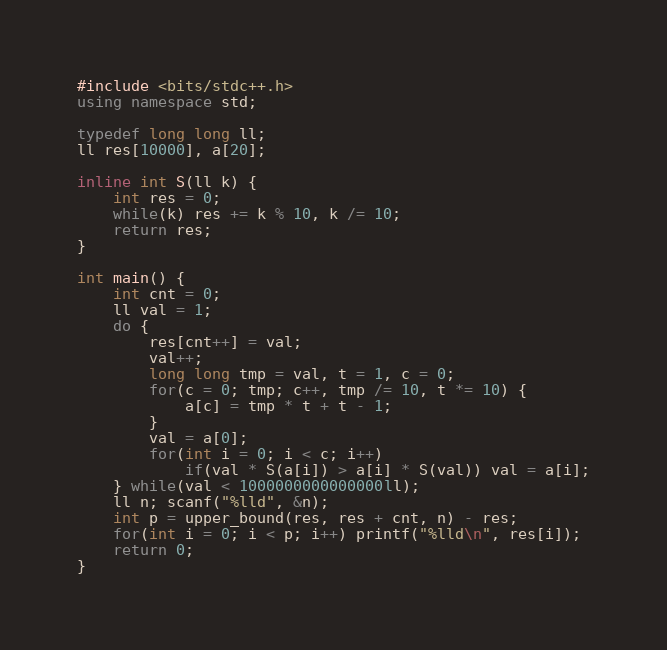Convert code to text. <code><loc_0><loc_0><loc_500><loc_500><_C++_>#include <bits/stdc++.h>
using namespace std;

typedef long long ll;
ll res[10000], a[20];

inline int S(ll k) {
	int res = 0;
	while(k) res += k % 10, k /= 10;
	return res;
}

int main() {
	int cnt = 0;
	ll val = 1;
	do {
		res[cnt++] = val;
		val++;
		long long tmp = val, t = 1, c = 0;
		for(c = 0; tmp; c++, tmp /= 10, t *= 10) {
			a[c] = tmp * t + t - 1;
		}
		val = a[0];
		for(int i = 0; i < c; i++)
			if(val * S(a[i]) > a[i] * S(val)) val = a[i];
	} while(val < 1000000000000000ll);
	ll n; scanf("%lld", &n);
	int p = upper_bound(res, res + cnt, n) - res;
	for(int i = 0; i < p; i++) printf("%lld\n", res[i]);
	return 0;
}
</code> 